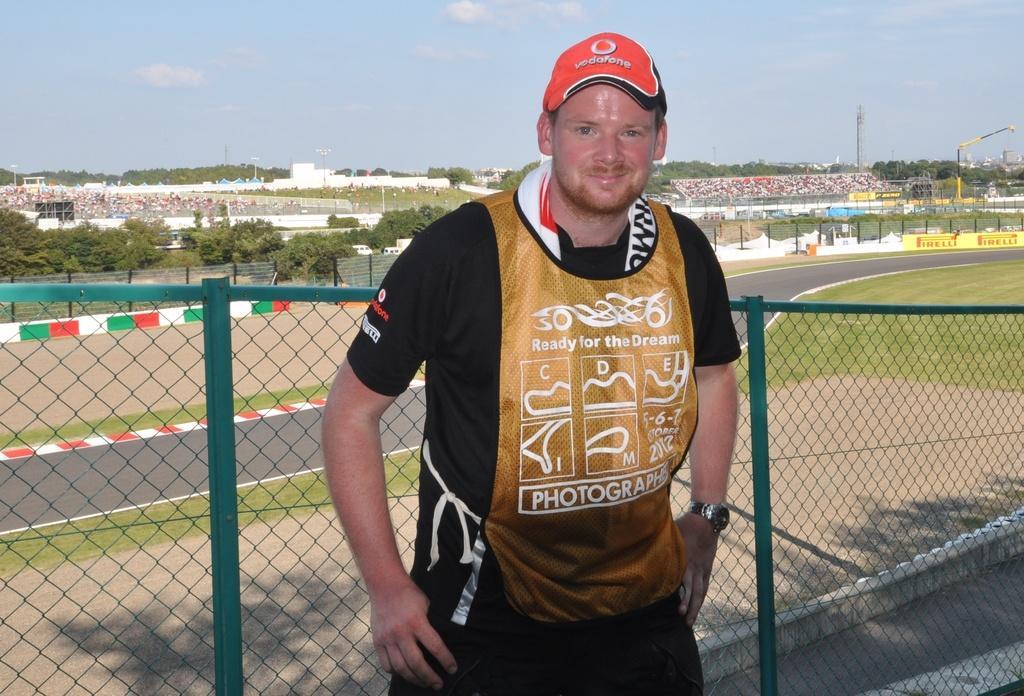Can you describe this image briefly? Here we can see a man standing at the fence. In the background we can see road,grass,poles,buildings,hoardings,audience sitting on the chairs,trees,cranes and clouds in the sky. 